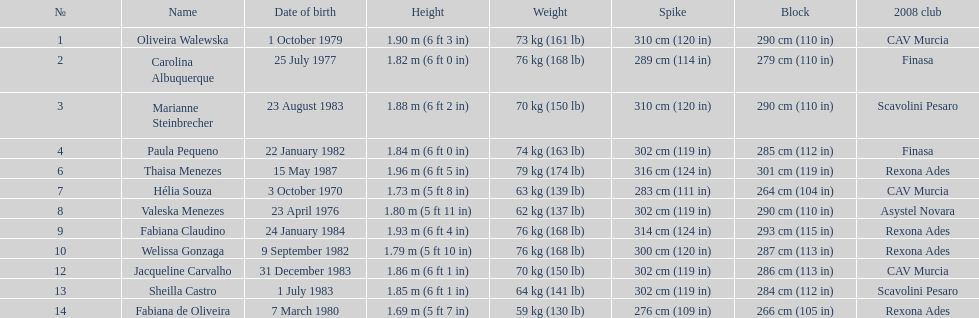Which player is the shortest at only 5 ft 7 in? Fabiana de Oliveira. 